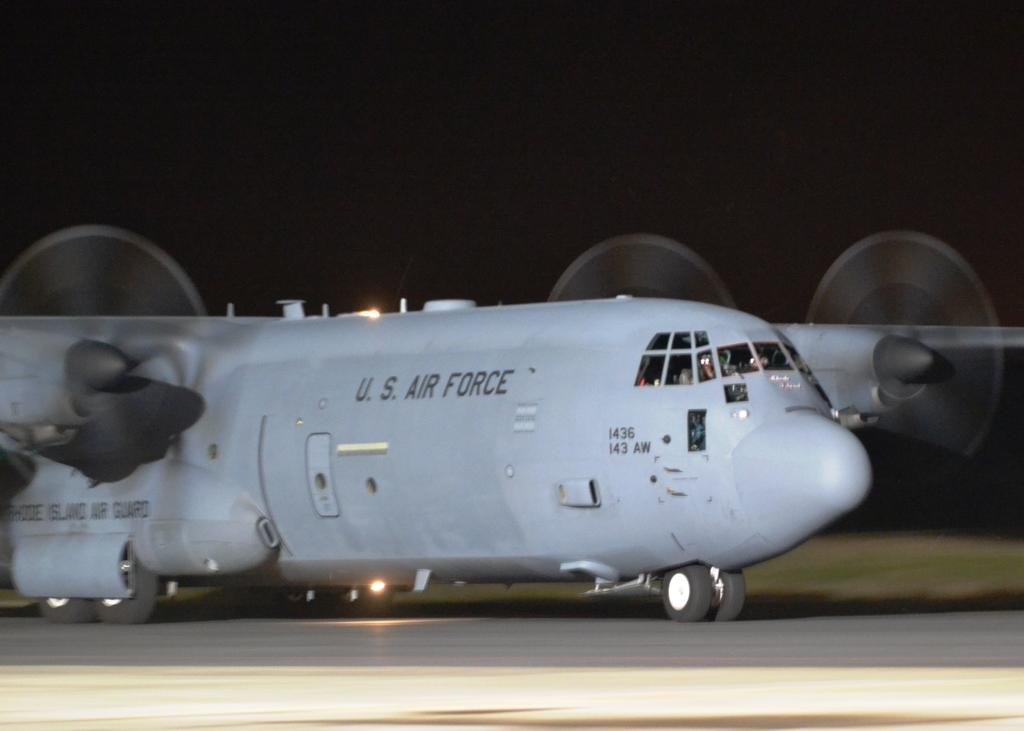What is the main subject of the image? The main subject of the image is an aircraft. Where is the aircraft located in the image? The aircraft is on a runway in the image. What features can be seen on the aircraft? The aircraft has wheels and lights. How would you describe the background of the image? The background of the image has a dark view. Can you see a baby playing with a squirrel in the hall near the aircraft? There is no baby, squirrel, or hall present in the image; it only features an aircraft on a runway with a dark background. 